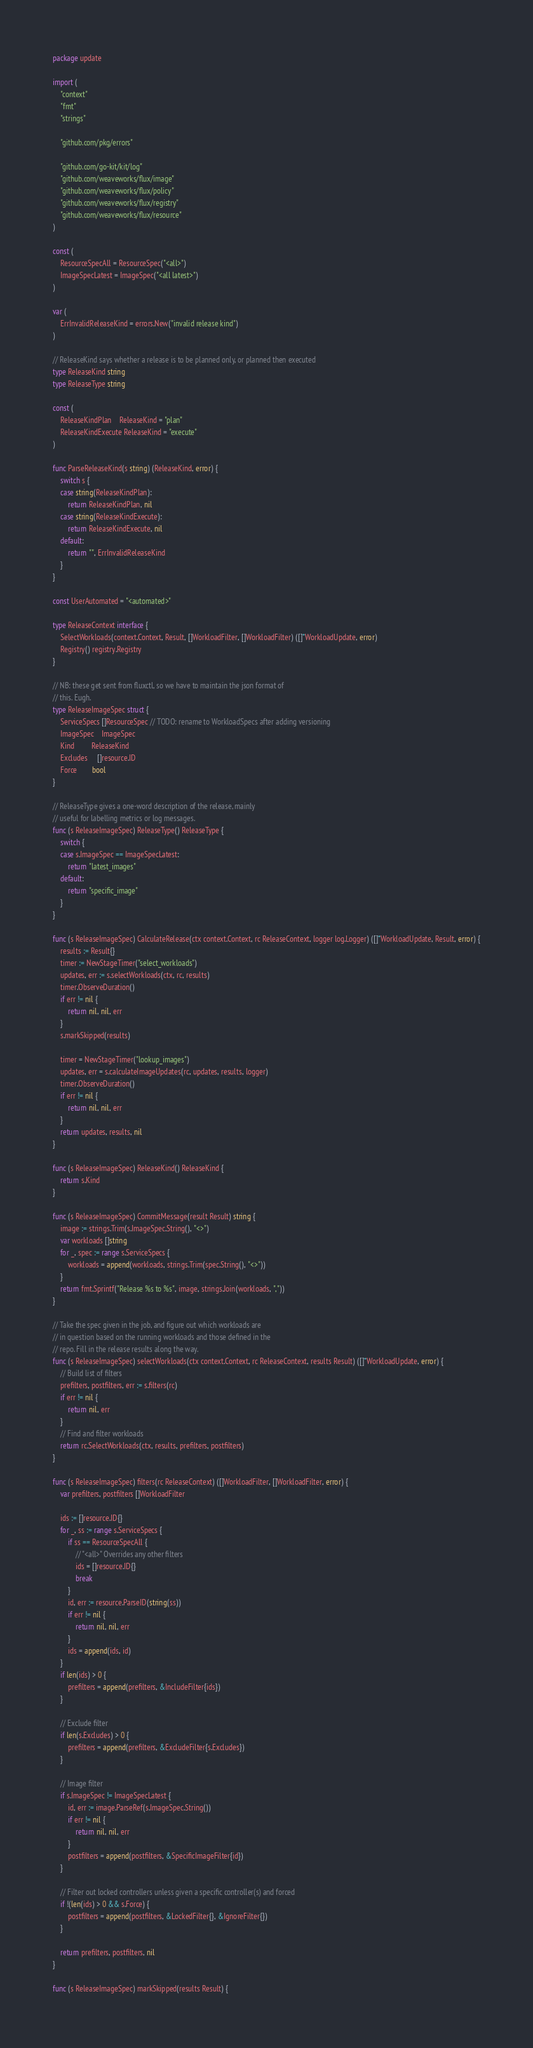<code> <loc_0><loc_0><loc_500><loc_500><_Go_>package update

import (
	"context"
	"fmt"
	"strings"

	"github.com/pkg/errors"

	"github.com/go-kit/kit/log"
	"github.com/weaveworks/flux/image"
	"github.com/weaveworks/flux/policy"
	"github.com/weaveworks/flux/registry"
	"github.com/weaveworks/flux/resource"
)

const (
	ResourceSpecAll = ResourceSpec("<all>")
	ImageSpecLatest = ImageSpec("<all latest>")
)

var (
	ErrInvalidReleaseKind = errors.New("invalid release kind")
)

// ReleaseKind says whether a release is to be planned only, or planned then executed
type ReleaseKind string
type ReleaseType string

const (
	ReleaseKindPlan    ReleaseKind = "plan"
	ReleaseKindExecute ReleaseKind = "execute"
)

func ParseReleaseKind(s string) (ReleaseKind, error) {
	switch s {
	case string(ReleaseKindPlan):
		return ReleaseKindPlan, nil
	case string(ReleaseKindExecute):
		return ReleaseKindExecute, nil
	default:
		return "", ErrInvalidReleaseKind
	}
}

const UserAutomated = "<automated>"

type ReleaseContext interface {
	SelectWorkloads(context.Context, Result, []WorkloadFilter, []WorkloadFilter) ([]*WorkloadUpdate, error)
	Registry() registry.Registry
}

// NB: these get sent from fluxctl, so we have to maintain the json format of
// this. Eugh.
type ReleaseImageSpec struct {
	ServiceSpecs []ResourceSpec // TODO: rename to WorkloadSpecs after adding versioning
	ImageSpec    ImageSpec
	Kind         ReleaseKind
	Excludes     []resource.ID
	Force        bool
}

// ReleaseType gives a one-word description of the release, mainly
// useful for labelling metrics or log messages.
func (s ReleaseImageSpec) ReleaseType() ReleaseType {
	switch {
	case s.ImageSpec == ImageSpecLatest:
		return "latest_images"
	default:
		return "specific_image"
	}
}

func (s ReleaseImageSpec) CalculateRelease(ctx context.Context, rc ReleaseContext, logger log.Logger) ([]*WorkloadUpdate, Result, error) {
	results := Result{}
	timer := NewStageTimer("select_workloads")
	updates, err := s.selectWorkloads(ctx, rc, results)
	timer.ObserveDuration()
	if err != nil {
		return nil, nil, err
	}
	s.markSkipped(results)

	timer = NewStageTimer("lookup_images")
	updates, err = s.calculateImageUpdates(rc, updates, results, logger)
	timer.ObserveDuration()
	if err != nil {
		return nil, nil, err
	}
	return updates, results, nil
}

func (s ReleaseImageSpec) ReleaseKind() ReleaseKind {
	return s.Kind
}

func (s ReleaseImageSpec) CommitMessage(result Result) string {
	image := strings.Trim(s.ImageSpec.String(), "<>")
	var workloads []string
	for _, spec := range s.ServiceSpecs {
		workloads = append(workloads, strings.Trim(spec.String(), "<>"))
	}
	return fmt.Sprintf("Release %s to %s", image, strings.Join(workloads, ", "))
}

// Take the spec given in the job, and figure out which workloads are
// in question based on the running workloads and those defined in the
// repo. Fill in the release results along the way.
func (s ReleaseImageSpec) selectWorkloads(ctx context.Context, rc ReleaseContext, results Result) ([]*WorkloadUpdate, error) {
	// Build list of filters
	prefilters, postfilters, err := s.filters(rc)
	if err != nil {
		return nil, err
	}
	// Find and filter workloads
	return rc.SelectWorkloads(ctx, results, prefilters, postfilters)
}

func (s ReleaseImageSpec) filters(rc ReleaseContext) ([]WorkloadFilter, []WorkloadFilter, error) {
	var prefilters, postfilters []WorkloadFilter

	ids := []resource.ID{}
	for _, ss := range s.ServiceSpecs {
		if ss == ResourceSpecAll {
			// "<all>" Overrides any other filters
			ids = []resource.ID{}
			break
		}
		id, err := resource.ParseID(string(ss))
		if err != nil {
			return nil, nil, err
		}
		ids = append(ids, id)
	}
	if len(ids) > 0 {
		prefilters = append(prefilters, &IncludeFilter{ids})
	}

	// Exclude filter
	if len(s.Excludes) > 0 {
		prefilters = append(prefilters, &ExcludeFilter{s.Excludes})
	}

	// Image filter
	if s.ImageSpec != ImageSpecLatest {
		id, err := image.ParseRef(s.ImageSpec.String())
		if err != nil {
			return nil, nil, err
		}
		postfilters = append(postfilters, &SpecificImageFilter{id})
	}

	// Filter out locked controllers unless given a specific controller(s) and forced
	if !(len(ids) > 0 && s.Force) {
		postfilters = append(postfilters, &LockedFilter{}, &IgnoreFilter{})
	}

	return prefilters, postfilters, nil
}

func (s ReleaseImageSpec) markSkipped(results Result) {</code> 